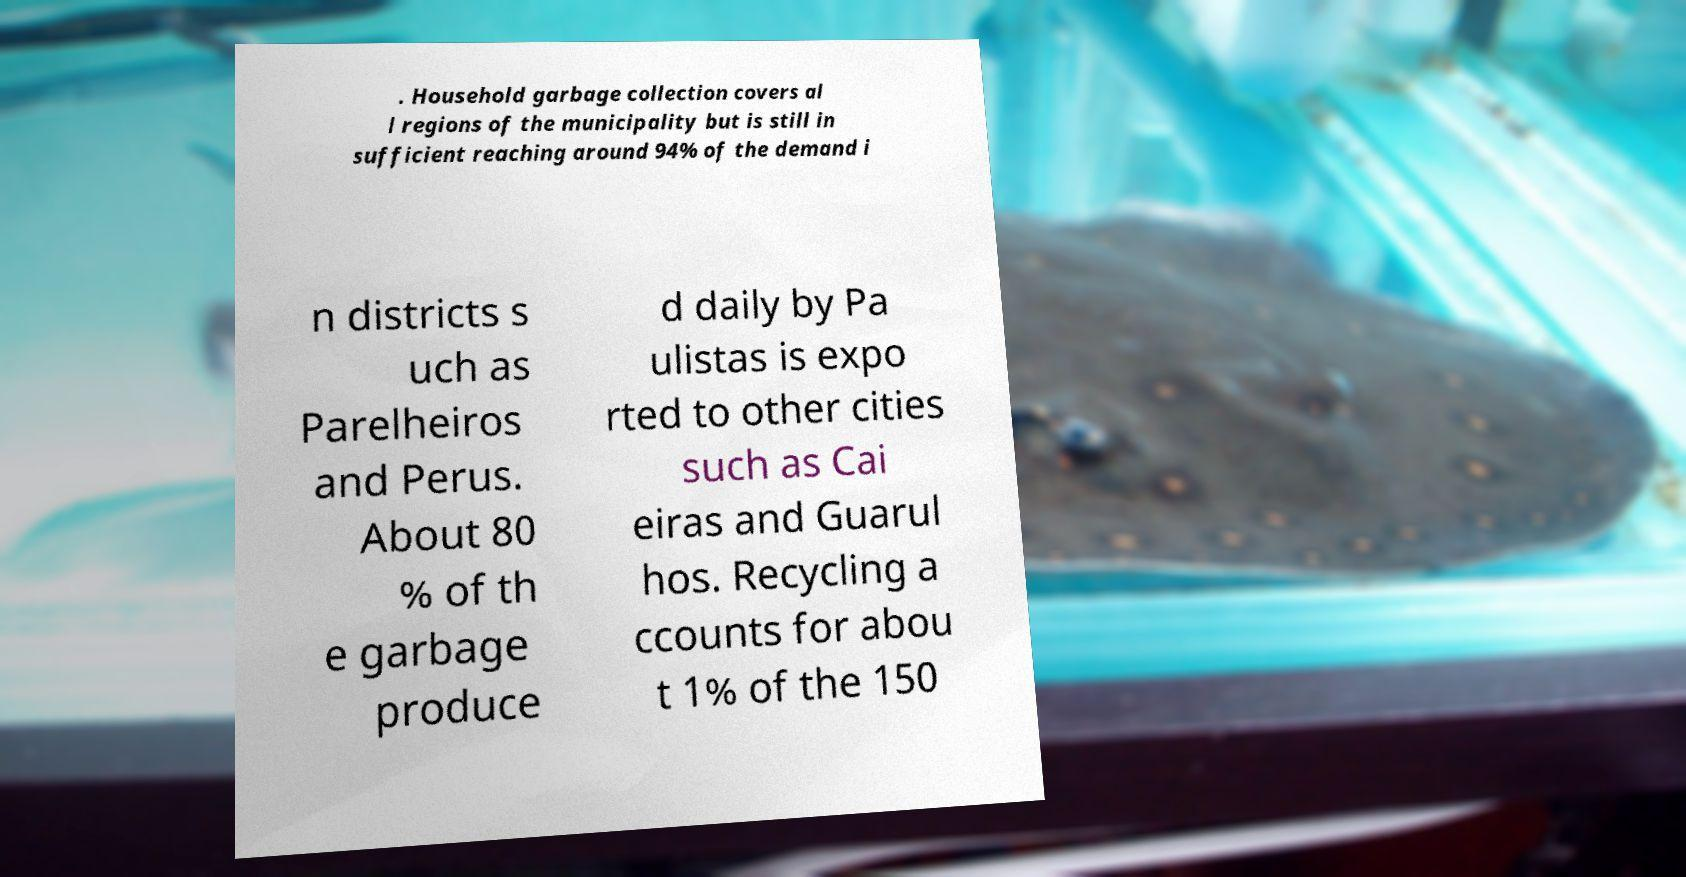Could you extract and type out the text from this image? . Household garbage collection covers al l regions of the municipality but is still in sufficient reaching around 94% of the demand i n districts s uch as Parelheiros and Perus. About 80 % of th e garbage produce d daily by Pa ulistas is expo rted to other cities such as Cai eiras and Guarul hos. Recycling a ccounts for abou t 1% of the 150 